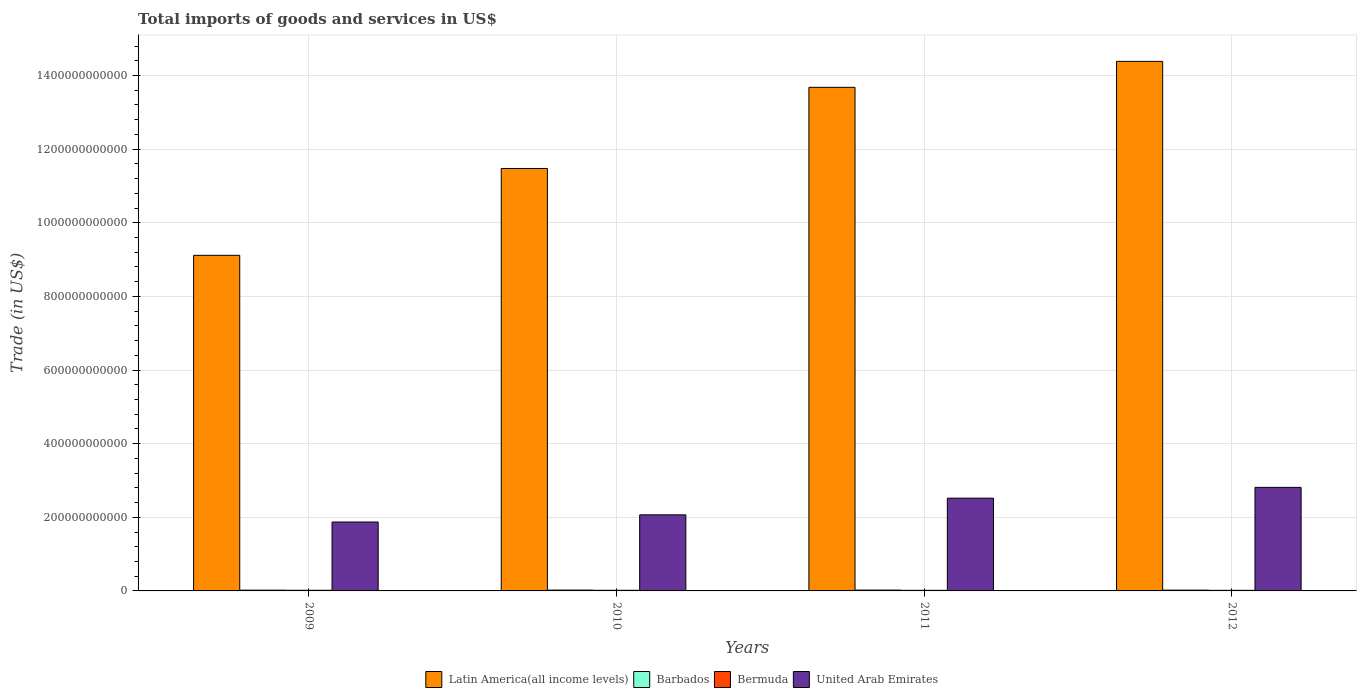How many groups of bars are there?
Provide a short and direct response. 4. Are the number of bars per tick equal to the number of legend labels?
Your response must be concise. Yes. How many bars are there on the 1st tick from the left?
Keep it short and to the point. 4. How many bars are there on the 3rd tick from the right?
Keep it short and to the point. 4. What is the label of the 1st group of bars from the left?
Give a very brief answer. 2009. What is the total imports of goods and services in Latin America(all income levels) in 2010?
Ensure brevity in your answer.  1.15e+12. Across all years, what is the maximum total imports of goods and services in Bermuda?
Keep it short and to the point. 1.77e+09. Across all years, what is the minimum total imports of goods and services in United Arab Emirates?
Keep it short and to the point. 1.87e+11. In which year was the total imports of goods and services in Barbados maximum?
Ensure brevity in your answer.  2011. In which year was the total imports of goods and services in Latin America(all income levels) minimum?
Offer a very short reply. 2009. What is the total total imports of goods and services in Barbados in the graph?
Offer a very short reply. 8.75e+09. What is the difference between the total imports of goods and services in Bermuda in 2010 and that in 2012?
Your response must be concise. 1.47e+08. What is the difference between the total imports of goods and services in Barbados in 2011 and the total imports of goods and services in United Arab Emirates in 2012?
Keep it short and to the point. -2.79e+11. What is the average total imports of goods and services in Bermuda per year?
Give a very brief answer. 1.67e+09. In the year 2012, what is the difference between the total imports of goods and services in United Arab Emirates and total imports of goods and services in Latin America(all income levels)?
Your answer should be very brief. -1.16e+12. What is the ratio of the total imports of goods and services in United Arab Emirates in 2009 to that in 2011?
Provide a succinct answer. 0.74. Is the total imports of goods and services in United Arab Emirates in 2010 less than that in 2012?
Your response must be concise. Yes. What is the difference between the highest and the second highest total imports of goods and services in Bermuda?
Your response must be concise. 3.76e+07. What is the difference between the highest and the lowest total imports of goods and services in Barbados?
Your answer should be compact. 2.42e+08. Is it the case that in every year, the sum of the total imports of goods and services in United Arab Emirates and total imports of goods and services in Latin America(all income levels) is greater than the sum of total imports of goods and services in Barbados and total imports of goods and services in Bermuda?
Provide a succinct answer. No. What does the 2nd bar from the left in 2011 represents?
Your answer should be compact. Barbados. What does the 3rd bar from the right in 2010 represents?
Provide a short and direct response. Barbados. Are all the bars in the graph horizontal?
Offer a very short reply. No. What is the difference between two consecutive major ticks on the Y-axis?
Offer a very short reply. 2.00e+11. Are the values on the major ticks of Y-axis written in scientific E-notation?
Your answer should be compact. No. What is the title of the graph?
Your response must be concise. Total imports of goods and services in US$. Does "Mauritius" appear as one of the legend labels in the graph?
Offer a terse response. No. What is the label or title of the Y-axis?
Your response must be concise. Trade (in US$). What is the Trade (in US$) in Latin America(all income levels) in 2009?
Provide a succinct answer. 9.12e+11. What is the Trade (in US$) in Barbados in 2009?
Your answer should be compact. 2.05e+09. What is the Trade (in US$) in Bermuda in 2009?
Provide a succinct answer. 1.77e+09. What is the Trade (in US$) of United Arab Emirates in 2009?
Your answer should be very brief. 1.87e+11. What is the Trade (in US$) of Latin America(all income levels) in 2010?
Your response must be concise. 1.15e+12. What is the Trade (in US$) in Barbados in 2010?
Provide a succinct answer. 2.24e+09. What is the Trade (in US$) of Bermuda in 2010?
Your answer should be compact. 1.73e+09. What is the Trade (in US$) in United Arab Emirates in 2010?
Provide a succinct answer. 2.07e+11. What is the Trade (in US$) in Latin America(all income levels) in 2011?
Your answer should be very brief. 1.37e+12. What is the Trade (in US$) in Barbados in 2011?
Your answer should be compact. 2.29e+09. What is the Trade (in US$) in Bermuda in 2011?
Your answer should be compact. 1.60e+09. What is the Trade (in US$) of United Arab Emirates in 2011?
Ensure brevity in your answer.  2.52e+11. What is the Trade (in US$) of Latin America(all income levels) in 2012?
Keep it short and to the point. 1.44e+12. What is the Trade (in US$) of Barbados in 2012?
Keep it short and to the point. 2.18e+09. What is the Trade (in US$) in Bermuda in 2012?
Offer a terse response. 1.59e+09. What is the Trade (in US$) of United Arab Emirates in 2012?
Provide a short and direct response. 2.81e+11. Across all years, what is the maximum Trade (in US$) of Latin America(all income levels)?
Offer a terse response. 1.44e+12. Across all years, what is the maximum Trade (in US$) in Barbados?
Make the answer very short. 2.29e+09. Across all years, what is the maximum Trade (in US$) of Bermuda?
Your answer should be compact. 1.77e+09. Across all years, what is the maximum Trade (in US$) of United Arab Emirates?
Offer a very short reply. 2.81e+11. Across all years, what is the minimum Trade (in US$) in Latin America(all income levels)?
Keep it short and to the point. 9.12e+11. Across all years, what is the minimum Trade (in US$) of Barbados?
Give a very brief answer. 2.05e+09. Across all years, what is the minimum Trade (in US$) of Bermuda?
Keep it short and to the point. 1.59e+09. Across all years, what is the minimum Trade (in US$) of United Arab Emirates?
Offer a very short reply. 1.87e+11. What is the total Trade (in US$) in Latin America(all income levels) in the graph?
Give a very brief answer. 4.87e+12. What is the total Trade (in US$) of Barbados in the graph?
Your response must be concise. 8.75e+09. What is the total Trade (in US$) of Bermuda in the graph?
Keep it short and to the point. 6.69e+09. What is the total Trade (in US$) of United Arab Emirates in the graph?
Keep it short and to the point. 9.27e+11. What is the difference between the Trade (in US$) of Latin America(all income levels) in 2009 and that in 2010?
Make the answer very short. -2.36e+11. What is the difference between the Trade (in US$) of Barbados in 2009 and that in 2010?
Your answer should be very brief. -1.94e+08. What is the difference between the Trade (in US$) of Bermuda in 2009 and that in 2010?
Ensure brevity in your answer.  3.76e+07. What is the difference between the Trade (in US$) in United Arab Emirates in 2009 and that in 2010?
Make the answer very short. -1.95e+1. What is the difference between the Trade (in US$) in Latin America(all income levels) in 2009 and that in 2011?
Your answer should be compact. -4.56e+11. What is the difference between the Trade (in US$) in Barbados in 2009 and that in 2011?
Give a very brief answer. -2.42e+08. What is the difference between the Trade (in US$) in Bermuda in 2009 and that in 2011?
Keep it short and to the point. 1.71e+08. What is the difference between the Trade (in US$) in United Arab Emirates in 2009 and that in 2011?
Offer a terse response. -6.48e+1. What is the difference between the Trade (in US$) in Latin America(all income levels) in 2009 and that in 2012?
Give a very brief answer. -5.27e+11. What is the difference between the Trade (in US$) of Barbados in 2009 and that in 2012?
Ensure brevity in your answer.  -1.30e+08. What is the difference between the Trade (in US$) in Bermuda in 2009 and that in 2012?
Your answer should be very brief. 1.85e+08. What is the difference between the Trade (in US$) in United Arab Emirates in 2009 and that in 2012?
Make the answer very short. -9.42e+1. What is the difference between the Trade (in US$) in Latin America(all income levels) in 2010 and that in 2011?
Your response must be concise. -2.20e+11. What is the difference between the Trade (in US$) of Barbados in 2010 and that in 2011?
Make the answer very short. -4.70e+07. What is the difference between the Trade (in US$) of Bermuda in 2010 and that in 2011?
Ensure brevity in your answer.  1.33e+08. What is the difference between the Trade (in US$) in United Arab Emirates in 2010 and that in 2011?
Provide a short and direct response. -4.53e+1. What is the difference between the Trade (in US$) in Latin America(all income levels) in 2010 and that in 2012?
Keep it short and to the point. -2.91e+11. What is the difference between the Trade (in US$) of Barbados in 2010 and that in 2012?
Make the answer very short. 6.45e+07. What is the difference between the Trade (in US$) of Bermuda in 2010 and that in 2012?
Keep it short and to the point. 1.47e+08. What is the difference between the Trade (in US$) in United Arab Emirates in 2010 and that in 2012?
Offer a terse response. -7.46e+1. What is the difference between the Trade (in US$) of Latin America(all income levels) in 2011 and that in 2012?
Your answer should be very brief. -7.06e+1. What is the difference between the Trade (in US$) of Barbados in 2011 and that in 2012?
Provide a succinct answer. 1.12e+08. What is the difference between the Trade (in US$) of Bermuda in 2011 and that in 2012?
Ensure brevity in your answer.  1.42e+07. What is the difference between the Trade (in US$) in United Arab Emirates in 2011 and that in 2012?
Provide a short and direct response. -2.93e+1. What is the difference between the Trade (in US$) in Latin America(all income levels) in 2009 and the Trade (in US$) in Barbados in 2010?
Offer a terse response. 9.09e+11. What is the difference between the Trade (in US$) of Latin America(all income levels) in 2009 and the Trade (in US$) of Bermuda in 2010?
Your answer should be compact. 9.10e+11. What is the difference between the Trade (in US$) in Latin America(all income levels) in 2009 and the Trade (in US$) in United Arab Emirates in 2010?
Your answer should be compact. 7.05e+11. What is the difference between the Trade (in US$) in Barbados in 2009 and the Trade (in US$) in Bermuda in 2010?
Offer a very short reply. 3.11e+08. What is the difference between the Trade (in US$) of Barbados in 2009 and the Trade (in US$) of United Arab Emirates in 2010?
Keep it short and to the point. -2.05e+11. What is the difference between the Trade (in US$) of Bermuda in 2009 and the Trade (in US$) of United Arab Emirates in 2010?
Your response must be concise. -2.05e+11. What is the difference between the Trade (in US$) in Latin America(all income levels) in 2009 and the Trade (in US$) in Barbados in 2011?
Provide a short and direct response. 9.09e+11. What is the difference between the Trade (in US$) in Latin America(all income levels) in 2009 and the Trade (in US$) in Bermuda in 2011?
Your response must be concise. 9.10e+11. What is the difference between the Trade (in US$) of Latin America(all income levels) in 2009 and the Trade (in US$) of United Arab Emirates in 2011?
Your answer should be compact. 6.60e+11. What is the difference between the Trade (in US$) of Barbados in 2009 and the Trade (in US$) of Bermuda in 2011?
Offer a terse response. 4.44e+08. What is the difference between the Trade (in US$) in Barbados in 2009 and the Trade (in US$) in United Arab Emirates in 2011?
Your answer should be compact. -2.50e+11. What is the difference between the Trade (in US$) of Bermuda in 2009 and the Trade (in US$) of United Arab Emirates in 2011?
Provide a short and direct response. -2.50e+11. What is the difference between the Trade (in US$) in Latin America(all income levels) in 2009 and the Trade (in US$) in Barbados in 2012?
Provide a succinct answer. 9.09e+11. What is the difference between the Trade (in US$) in Latin America(all income levels) in 2009 and the Trade (in US$) in Bermuda in 2012?
Offer a very short reply. 9.10e+11. What is the difference between the Trade (in US$) in Latin America(all income levels) in 2009 and the Trade (in US$) in United Arab Emirates in 2012?
Keep it short and to the point. 6.30e+11. What is the difference between the Trade (in US$) in Barbados in 2009 and the Trade (in US$) in Bermuda in 2012?
Offer a very short reply. 4.59e+08. What is the difference between the Trade (in US$) in Barbados in 2009 and the Trade (in US$) in United Arab Emirates in 2012?
Make the answer very short. -2.79e+11. What is the difference between the Trade (in US$) of Bermuda in 2009 and the Trade (in US$) of United Arab Emirates in 2012?
Your answer should be very brief. -2.80e+11. What is the difference between the Trade (in US$) in Latin America(all income levels) in 2010 and the Trade (in US$) in Barbados in 2011?
Provide a succinct answer. 1.15e+12. What is the difference between the Trade (in US$) of Latin America(all income levels) in 2010 and the Trade (in US$) of Bermuda in 2011?
Keep it short and to the point. 1.15e+12. What is the difference between the Trade (in US$) in Latin America(all income levels) in 2010 and the Trade (in US$) in United Arab Emirates in 2011?
Offer a terse response. 8.95e+11. What is the difference between the Trade (in US$) in Barbados in 2010 and the Trade (in US$) in Bermuda in 2011?
Keep it short and to the point. 6.39e+08. What is the difference between the Trade (in US$) of Barbados in 2010 and the Trade (in US$) of United Arab Emirates in 2011?
Your answer should be very brief. -2.50e+11. What is the difference between the Trade (in US$) of Bermuda in 2010 and the Trade (in US$) of United Arab Emirates in 2011?
Make the answer very short. -2.50e+11. What is the difference between the Trade (in US$) of Latin America(all income levels) in 2010 and the Trade (in US$) of Barbados in 2012?
Give a very brief answer. 1.15e+12. What is the difference between the Trade (in US$) of Latin America(all income levels) in 2010 and the Trade (in US$) of Bermuda in 2012?
Offer a very short reply. 1.15e+12. What is the difference between the Trade (in US$) of Latin America(all income levels) in 2010 and the Trade (in US$) of United Arab Emirates in 2012?
Give a very brief answer. 8.66e+11. What is the difference between the Trade (in US$) of Barbados in 2010 and the Trade (in US$) of Bermuda in 2012?
Provide a succinct answer. 6.53e+08. What is the difference between the Trade (in US$) of Barbados in 2010 and the Trade (in US$) of United Arab Emirates in 2012?
Make the answer very short. -2.79e+11. What is the difference between the Trade (in US$) of Bermuda in 2010 and the Trade (in US$) of United Arab Emirates in 2012?
Provide a succinct answer. -2.80e+11. What is the difference between the Trade (in US$) of Latin America(all income levels) in 2011 and the Trade (in US$) of Barbados in 2012?
Your answer should be very brief. 1.37e+12. What is the difference between the Trade (in US$) in Latin America(all income levels) in 2011 and the Trade (in US$) in Bermuda in 2012?
Your response must be concise. 1.37e+12. What is the difference between the Trade (in US$) of Latin America(all income levels) in 2011 and the Trade (in US$) of United Arab Emirates in 2012?
Your response must be concise. 1.09e+12. What is the difference between the Trade (in US$) of Barbados in 2011 and the Trade (in US$) of Bermuda in 2012?
Provide a succinct answer. 7.00e+08. What is the difference between the Trade (in US$) in Barbados in 2011 and the Trade (in US$) in United Arab Emirates in 2012?
Offer a terse response. -2.79e+11. What is the difference between the Trade (in US$) of Bermuda in 2011 and the Trade (in US$) of United Arab Emirates in 2012?
Give a very brief answer. -2.80e+11. What is the average Trade (in US$) of Latin America(all income levels) per year?
Your response must be concise. 1.22e+12. What is the average Trade (in US$) of Barbados per year?
Offer a terse response. 2.19e+09. What is the average Trade (in US$) of Bermuda per year?
Your answer should be very brief. 1.67e+09. What is the average Trade (in US$) in United Arab Emirates per year?
Provide a succinct answer. 2.32e+11. In the year 2009, what is the difference between the Trade (in US$) in Latin America(all income levels) and Trade (in US$) in Barbados?
Offer a terse response. 9.09e+11. In the year 2009, what is the difference between the Trade (in US$) of Latin America(all income levels) and Trade (in US$) of Bermuda?
Offer a very short reply. 9.10e+11. In the year 2009, what is the difference between the Trade (in US$) of Latin America(all income levels) and Trade (in US$) of United Arab Emirates?
Your answer should be compact. 7.24e+11. In the year 2009, what is the difference between the Trade (in US$) of Barbados and Trade (in US$) of Bermuda?
Ensure brevity in your answer.  2.74e+08. In the year 2009, what is the difference between the Trade (in US$) in Barbados and Trade (in US$) in United Arab Emirates?
Make the answer very short. -1.85e+11. In the year 2009, what is the difference between the Trade (in US$) in Bermuda and Trade (in US$) in United Arab Emirates?
Give a very brief answer. -1.85e+11. In the year 2010, what is the difference between the Trade (in US$) of Latin America(all income levels) and Trade (in US$) of Barbados?
Keep it short and to the point. 1.15e+12. In the year 2010, what is the difference between the Trade (in US$) of Latin America(all income levels) and Trade (in US$) of Bermuda?
Offer a terse response. 1.15e+12. In the year 2010, what is the difference between the Trade (in US$) in Latin America(all income levels) and Trade (in US$) in United Arab Emirates?
Provide a short and direct response. 9.41e+11. In the year 2010, what is the difference between the Trade (in US$) in Barbados and Trade (in US$) in Bermuda?
Your answer should be compact. 5.06e+08. In the year 2010, what is the difference between the Trade (in US$) in Barbados and Trade (in US$) in United Arab Emirates?
Your answer should be compact. -2.04e+11. In the year 2010, what is the difference between the Trade (in US$) of Bermuda and Trade (in US$) of United Arab Emirates?
Make the answer very short. -2.05e+11. In the year 2011, what is the difference between the Trade (in US$) in Latin America(all income levels) and Trade (in US$) in Barbados?
Ensure brevity in your answer.  1.37e+12. In the year 2011, what is the difference between the Trade (in US$) of Latin America(all income levels) and Trade (in US$) of Bermuda?
Give a very brief answer. 1.37e+12. In the year 2011, what is the difference between the Trade (in US$) in Latin America(all income levels) and Trade (in US$) in United Arab Emirates?
Provide a succinct answer. 1.12e+12. In the year 2011, what is the difference between the Trade (in US$) in Barbados and Trade (in US$) in Bermuda?
Ensure brevity in your answer.  6.86e+08. In the year 2011, what is the difference between the Trade (in US$) in Barbados and Trade (in US$) in United Arab Emirates?
Your answer should be compact. -2.50e+11. In the year 2011, what is the difference between the Trade (in US$) in Bermuda and Trade (in US$) in United Arab Emirates?
Your response must be concise. -2.50e+11. In the year 2012, what is the difference between the Trade (in US$) in Latin America(all income levels) and Trade (in US$) in Barbados?
Keep it short and to the point. 1.44e+12. In the year 2012, what is the difference between the Trade (in US$) in Latin America(all income levels) and Trade (in US$) in Bermuda?
Provide a succinct answer. 1.44e+12. In the year 2012, what is the difference between the Trade (in US$) in Latin America(all income levels) and Trade (in US$) in United Arab Emirates?
Ensure brevity in your answer.  1.16e+12. In the year 2012, what is the difference between the Trade (in US$) in Barbados and Trade (in US$) in Bermuda?
Offer a very short reply. 5.89e+08. In the year 2012, what is the difference between the Trade (in US$) of Barbados and Trade (in US$) of United Arab Emirates?
Offer a terse response. -2.79e+11. In the year 2012, what is the difference between the Trade (in US$) of Bermuda and Trade (in US$) of United Arab Emirates?
Offer a very short reply. -2.80e+11. What is the ratio of the Trade (in US$) of Latin America(all income levels) in 2009 to that in 2010?
Provide a short and direct response. 0.79. What is the ratio of the Trade (in US$) in Barbados in 2009 to that in 2010?
Offer a very short reply. 0.91. What is the ratio of the Trade (in US$) of Bermuda in 2009 to that in 2010?
Provide a succinct answer. 1.02. What is the ratio of the Trade (in US$) in United Arab Emirates in 2009 to that in 2010?
Your answer should be very brief. 0.91. What is the ratio of the Trade (in US$) of Latin America(all income levels) in 2009 to that in 2011?
Offer a very short reply. 0.67. What is the ratio of the Trade (in US$) of Barbados in 2009 to that in 2011?
Your response must be concise. 0.89. What is the ratio of the Trade (in US$) in Bermuda in 2009 to that in 2011?
Your answer should be compact. 1.11. What is the ratio of the Trade (in US$) in United Arab Emirates in 2009 to that in 2011?
Offer a very short reply. 0.74. What is the ratio of the Trade (in US$) of Latin America(all income levels) in 2009 to that in 2012?
Keep it short and to the point. 0.63. What is the ratio of the Trade (in US$) of Barbados in 2009 to that in 2012?
Your response must be concise. 0.94. What is the ratio of the Trade (in US$) of Bermuda in 2009 to that in 2012?
Make the answer very short. 1.12. What is the ratio of the Trade (in US$) of United Arab Emirates in 2009 to that in 2012?
Provide a short and direct response. 0.67. What is the ratio of the Trade (in US$) of Latin America(all income levels) in 2010 to that in 2011?
Keep it short and to the point. 0.84. What is the ratio of the Trade (in US$) of Barbados in 2010 to that in 2011?
Keep it short and to the point. 0.98. What is the ratio of the Trade (in US$) of Bermuda in 2010 to that in 2011?
Give a very brief answer. 1.08. What is the ratio of the Trade (in US$) in United Arab Emirates in 2010 to that in 2011?
Make the answer very short. 0.82. What is the ratio of the Trade (in US$) in Latin America(all income levels) in 2010 to that in 2012?
Make the answer very short. 0.8. What is the ratio of the Trade (in US$) in Barbados in 2010 to that in 2012?
Provide a short and direct response. 1.03. What is the ratio of the Trade (in US$) in Bermuda in 2010 to that in 2012?
Keep it short and to the point. 1.09. What is the ratio of the Trade (in US$) of United Arab Emirates in 2010 to that in 2012?
Your response must be concise. 0.73. What is the ratio of the Trade (in US$) of Latin America(all income levels) in 2011 to that in 2012?
Your answer should be compact. 0.95. What is the ratio of the Trade (in US$) in Barbados in 2011 to that in 2012?
Your answer should be very brief. 1.05. What is the ratio of the Trade (in US$) in United Arab Emirates in 2011 to that in 2012?
Make the answer very short. 0.9. What is the difference between the highest and the second highest Trade (in US$) of Latin America(all income levels)?
Your response must be concise. 7.06e+1. What is the difference between the highest and the second highest Trade (in US$) of Barbados?
Give a very brief answer. 4.70e+07. What is the difference between the highest and the second highest Trade (in US$) in Bermuda?
Your response must be concise. 3.76e+07. What is the difference between the highest and the second highest Trade (in US$) in United Arab Emirates?
Give a very brief answer. 2.93e+1. What is the difference between the highest and the lowest Trade (in US$) of Latin America(all income levels)?
Provide a short and direct response. 5.27e+11. What is the difference between the highest and the lowest Trade (in US$) in Barbados?
Make the answer very short. 2.42e+08. What is the difference between the highest and the lowest Trade (in US$) of Bermuda?
Offer a terse response. 1.85e+08. What is the difference between the highest and the lowest Trade (in US$) of United Arab Emirates?
Ensure brevity in your answer.  9.42e+1. 